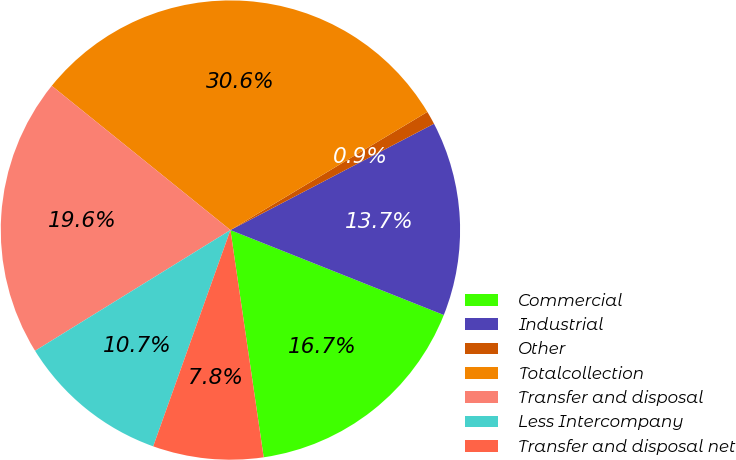<chart> <loc_0><loc_0><loc_500><loc_500><pie_chart><fcel>Commercial<fcel>Industrial<fcel>Other<fcel>Totalcollection<fcel>Transfer and disposal<fcel>Less Intercompany<fcel>Transfer and disposal net<nl><fcel>16.66%<fcel>13.69%<fcel>0.94%<fcel>30.59%<fcel>19.62%<fcel>10.73%<fcel>7.77%<nl></chart> 